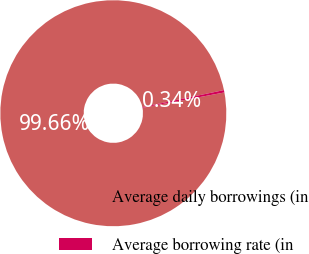<chart> <loc_0><loc_0><loc_500><loc_500><pie_chart><fcel>Average daily borrowings (in<fcel>Average borrowing rate (in<nl><fcel>99.66%<fcel>0.34%<nl></chart> 